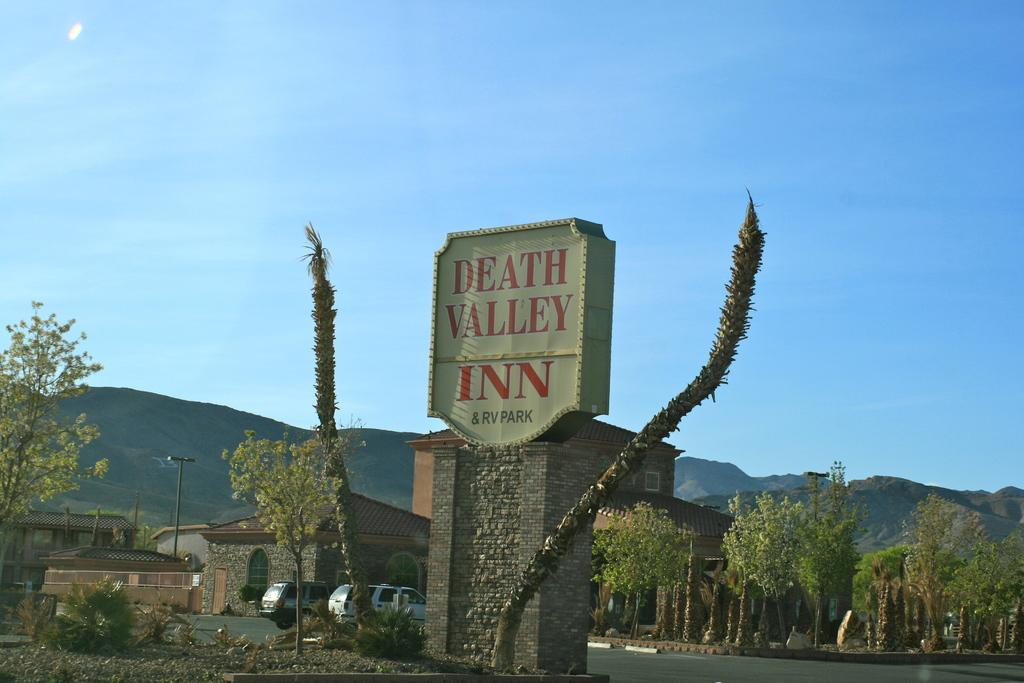What is the main object in the image? There is a name board in the image. What type of natural elements can be seen in the image? There are trees in the image. What type of structures are visible in the image? There are buildings with windows in the image. What is the pole used for in the image? The purpose of the pole is not specified in the image. What type of transportation is present in the image? There are vehicles on the road in the image. What can be seen in the distance in the image? There are hills visible in the background of the image. What is visible above the hills in the image? The sky is visible in the background of the image. What type of riddle is written on the name board in the image? There is no riddle written on the name board in the image. 